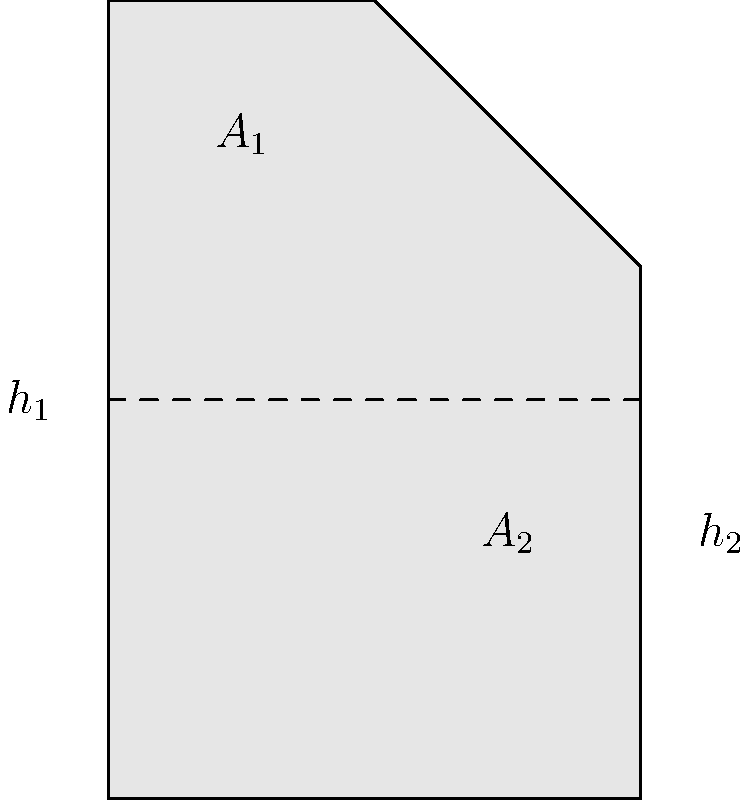A fluid-filled container has two sections with cross-sectional areas $A_1$ and $A_2$, as shown in the figure. The heights of fluid in each section are $h_1$ and $h_2$, respectively. If the density of the fluid is $\rho$, what is the difference in pressure between the bottom of the container and the fluid surface? To solve this problem, we'll use the principle of hydrostatic pressure. Let's approach this step-by-step:

1) The pressure at any point in a fluid at rest is given by the formula:
   $$P = \rho gh$$
   where $P$ is pressure, $\rho$ is fluid density, $g$ is acceleration due to gravity, and $h$ is the height of fluid above the point.

2) In this case, we need to find the pressure at the bottom of the container. The total height of fluid is $h_1 + h_2$.

3) Therefore, the pressure at the bottom is:
   $$P_{bottom} = \rho g(h_1 + h_2)$$

4) The pressure at the surface of the fluid is equal to atmospheric pressure, which we typically consider as zero gauge pressure.
   $$P_{surface} = 0$$

5) The difference in pressure between the bottom and the surface is:
   $$\Delta P = P_{bottom} - P_{surface} = \rho g(h_1 + h_2) - 0 = \rho g(h_1 + h_2)$$

This result shows that the pressure difference depends only on the total height of the fluid column and not on the shape of the container or the varying cross-sections.
Answer: $\rho g(h_1 + h_2)$ 